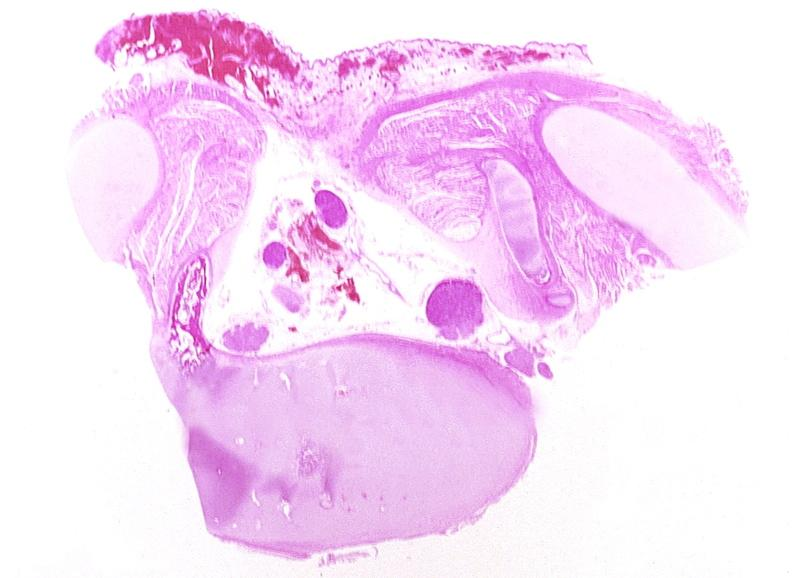where is this?
Answer the question using a single word or phrase. Nervous 